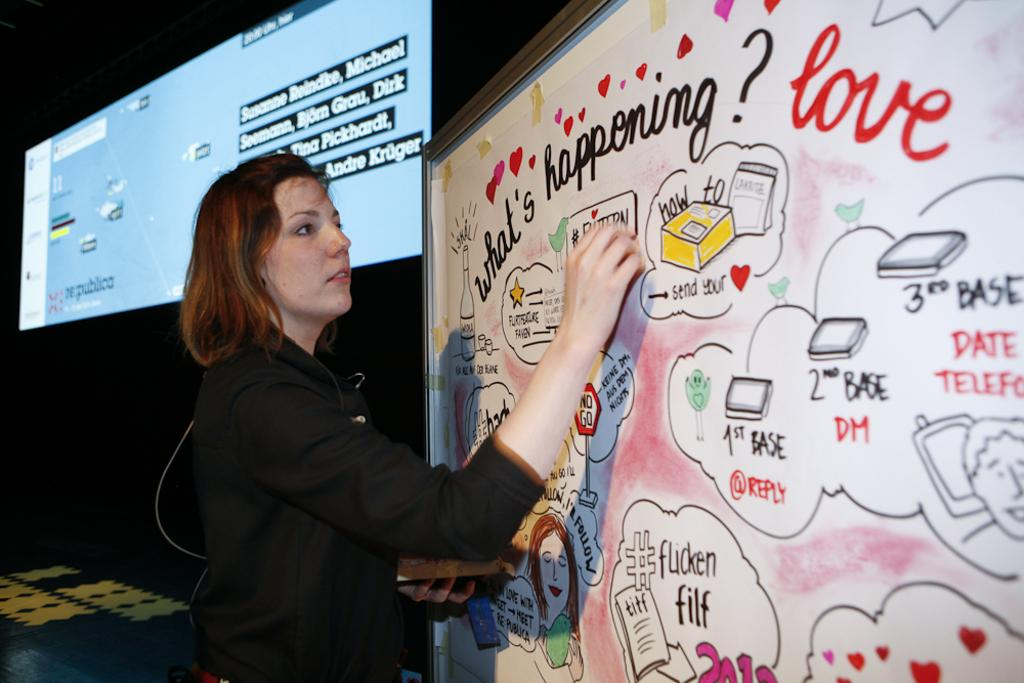Who is the main subject in the image? There is a woman in the image. What is the woman wearing? The woman is wearing a black coat. What is the woman doing in the image? The woman is writing on a board. What can be seen in the background of the image? There is a screen in the background of the image. Can you see a banana in the woman's hand while she is writing on the board? No, there is no banana present in the image. What type of lipstick is the woman wearing in the image? There is no lipstick or any indication of makeup on the woman in the image. 